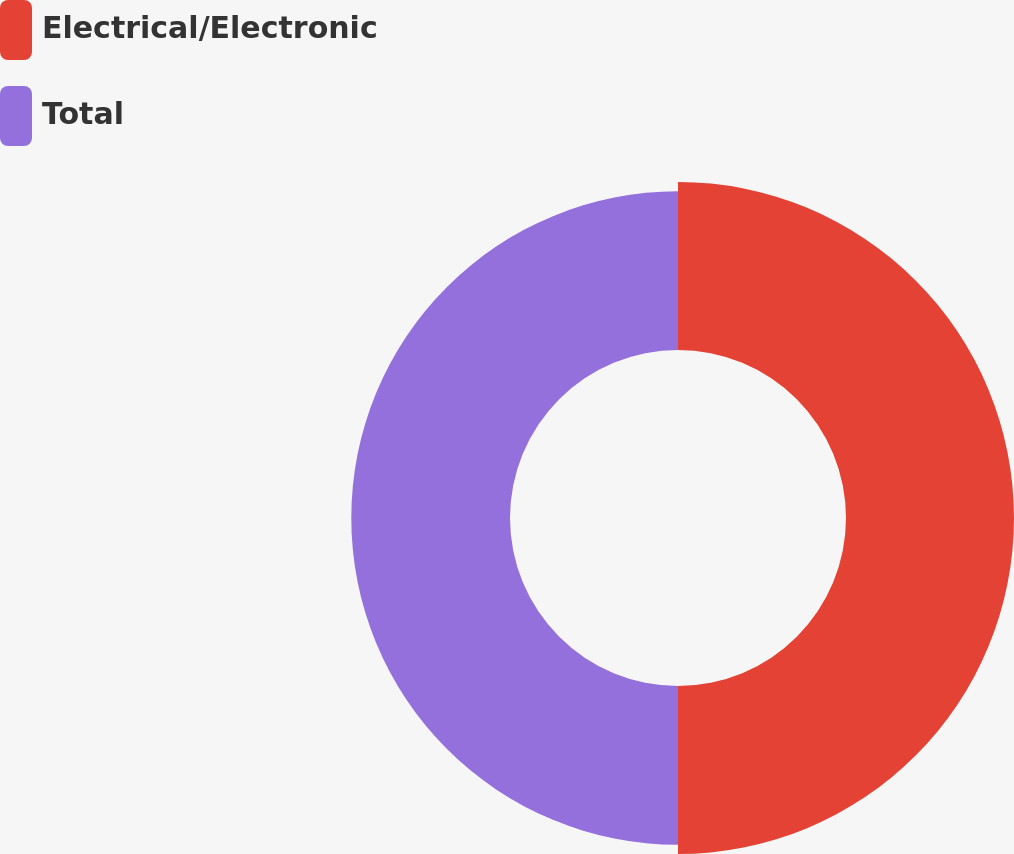Convert chart. <chart><loc_0><loc_0><loc_500><loc_500><pie_chart><fcel>Electrical/Electronic<fcel>Total<nl><fcel>51.42%<fcel>48.58%<nl></chart> 